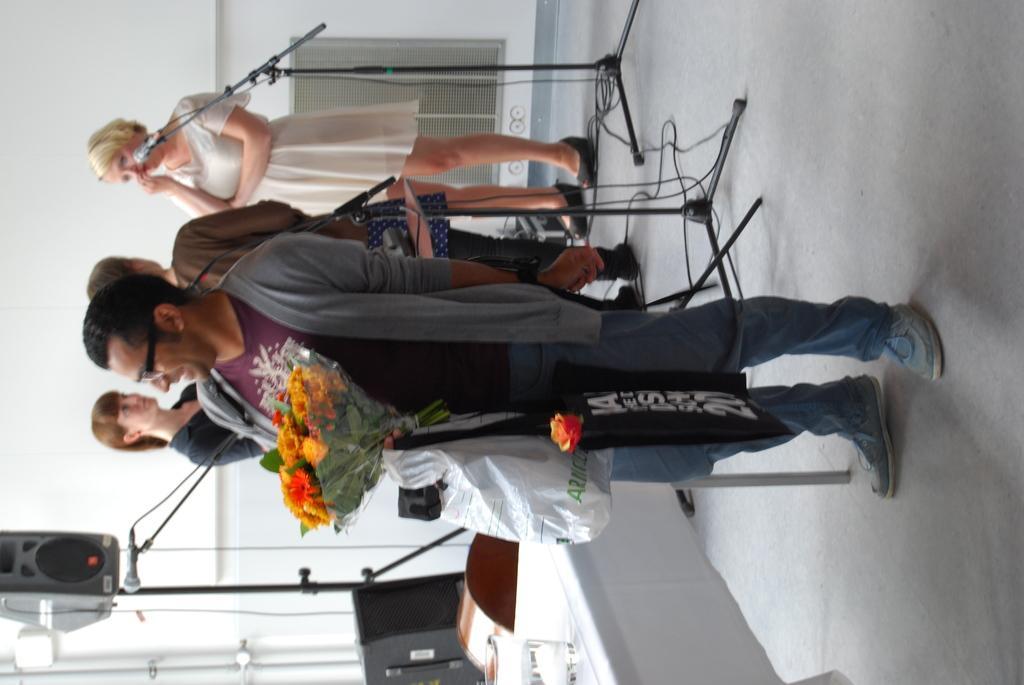How would you summarize this image in a sentence or two? In this image we can see a group of people standing. In that a man is holding a flower bouquet. We can also see some mics with stand and wires, a speaker with a stand and a table. On the backside we can see a wall. 